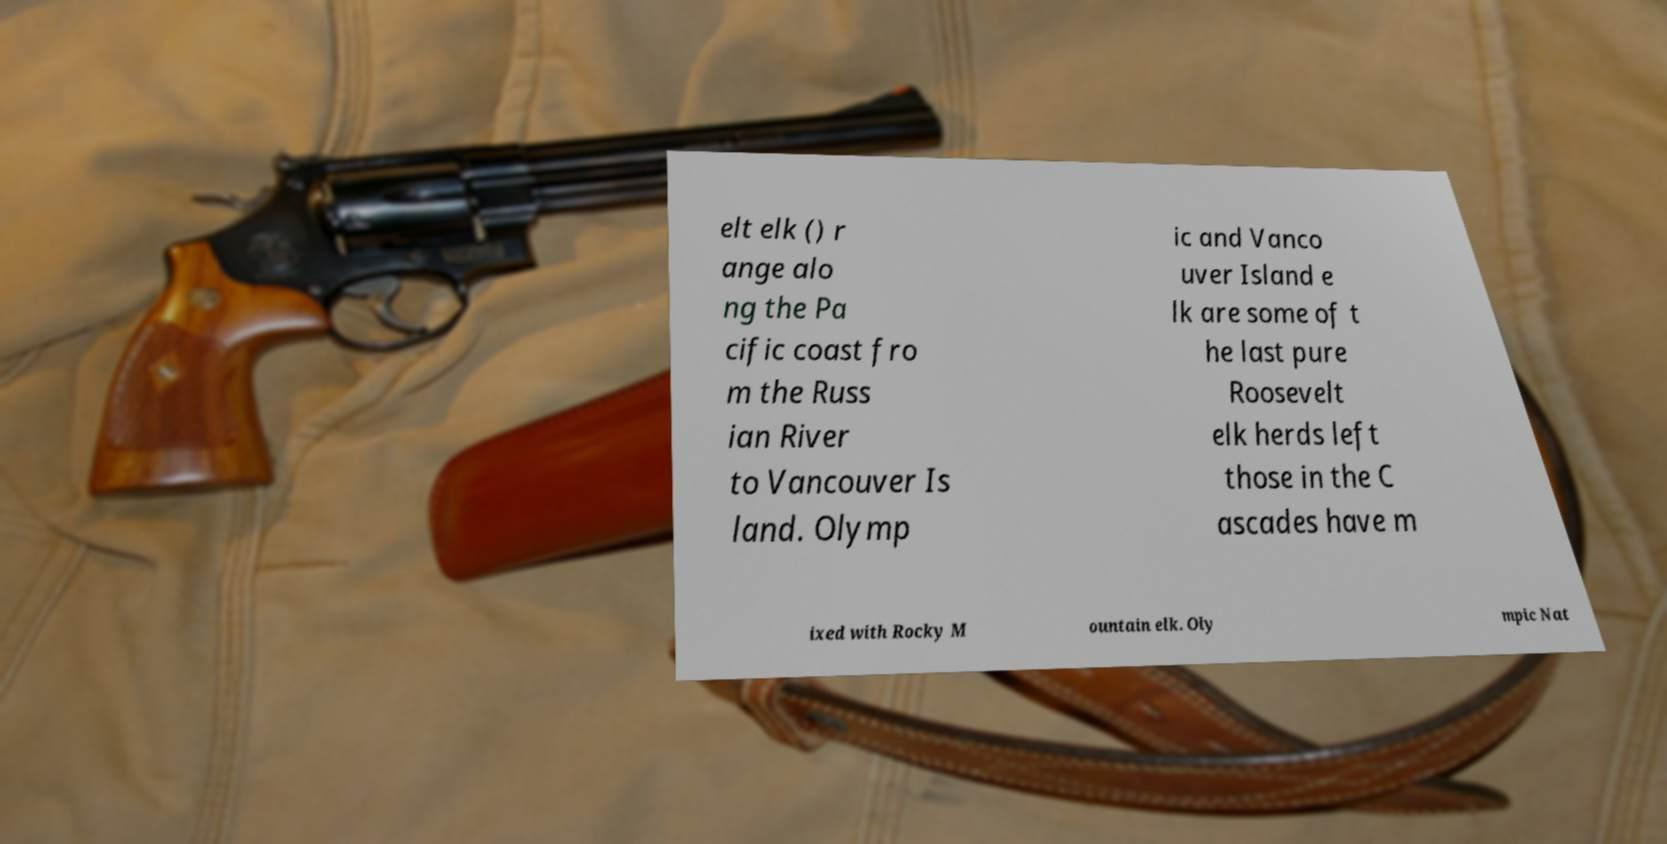I need the written content from this picture converted into text. Can you do that? elt elk () r ange alo ng the Pa cific coast fro m the Russ ian River to Vancouver Is land. Olymp ic and Vanco uver Island e lk are some of t he last pure Roosevelt elk herds left those in the C ascades have m ixed with Rocky M ountain elk. Oly mpic Nat 